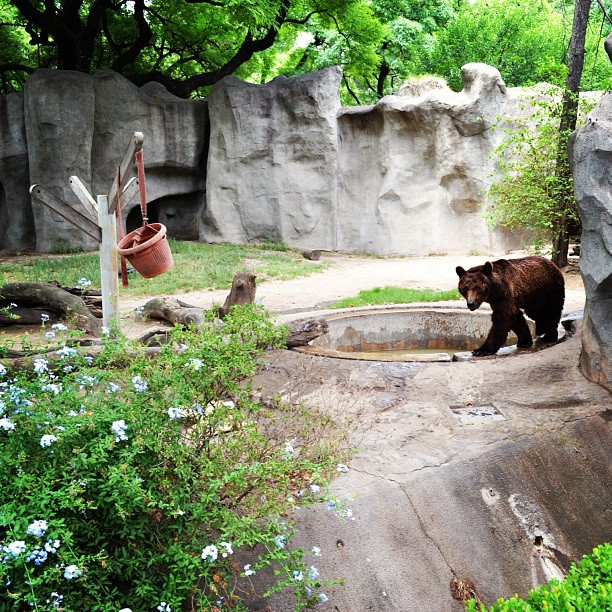<image>What toys does the bear have? I don't know what toys the bear has. The answer could be none, a bucket, or a ball. What toys does the bear have? The bear doesn't have any toys. 